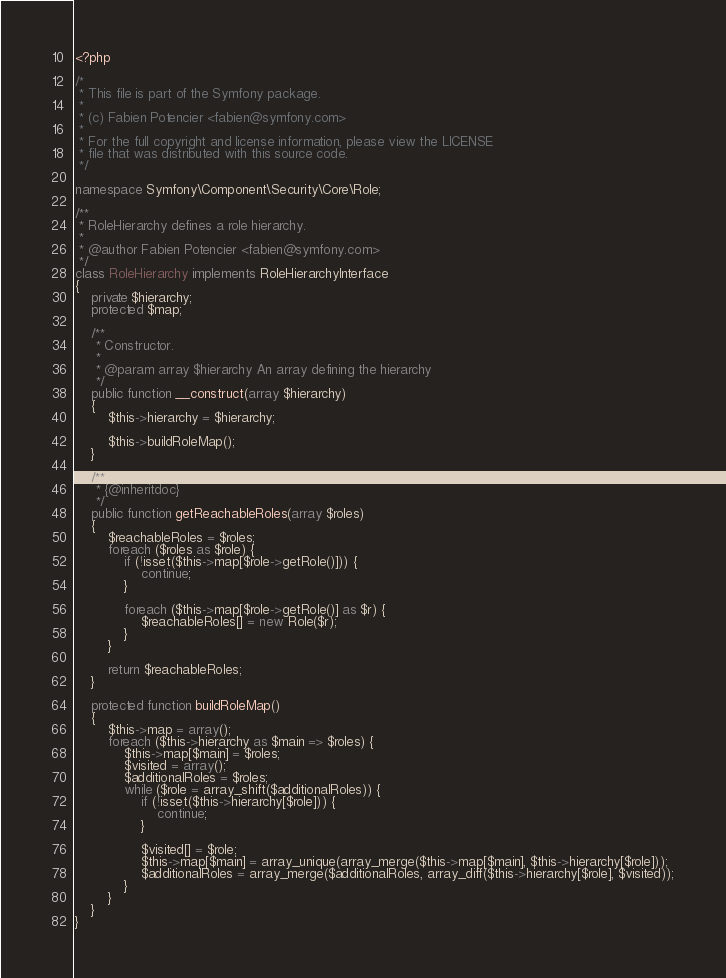Convert code to text. <code><loc_0><loc_0><loc_500><loc_500><_PHP_><?php

/*
 * This file is part of the Symfony package.
 *
 * (c) Fabien Potencier <fabien@symfony.com>
 *
 * For the full copyright and license information, please view the LICENSE
 * file that was distributed with this source code.
 */

namespace Symfony\Component\Security\Core\Role;

/**
 * RoleHierarchy defines a role hierarchy.
 *
 * @author Fabien Potencier <fabien@symfony.com>
 */
class RoleHierarchy implements RoleHierarchyInterface
{
    private $hierarchy;
    protected $map;

    /**
     * Constructor.
     *
     * @param array $hierarchy An array defining the hierarchy
     */
    public function __construct(array $hierarchy)
    {
        $this->hierarchy = $hierarchy;

        $this->buildRoleMap();
    }

    /**
     * {@inheritdoc}
     */
    public function getReachableRoles(array $roles)
    {
        $reachableRoles = $roles;
        foreach ($roles as $role) {
            if (!isset($this->map[$role->getRole()])) {
                continue;
            }

            foreach ($this->map[$role->getRole()] as $r) {
                $reachableRoles[] = new Role($r);
            }
        }

        return $reachableRoles;
    }

    protected function buildRoleMap()
    {
        $this->map = array();
        foreach ($this->hierarchy as $main => $roles) {
            $this->map[$main] = $roles;
            $visited = array();
            $additionalRoles = $roles;
            while ($role = array_shift($additionalRoles)) {
                if (!isset($this->hierarchy[$role])) {
                    continue;
                }

                $visited[] = $role;
                $this->map[$main] = array_unique(array_merge($this->map[$main], $this->hierarchy[$role]));
                $additionalRoles = array_merge($additionalRoles, array_diff($this->hierarchy[$role], $visited));
            }
        }
    }
}
</code> 